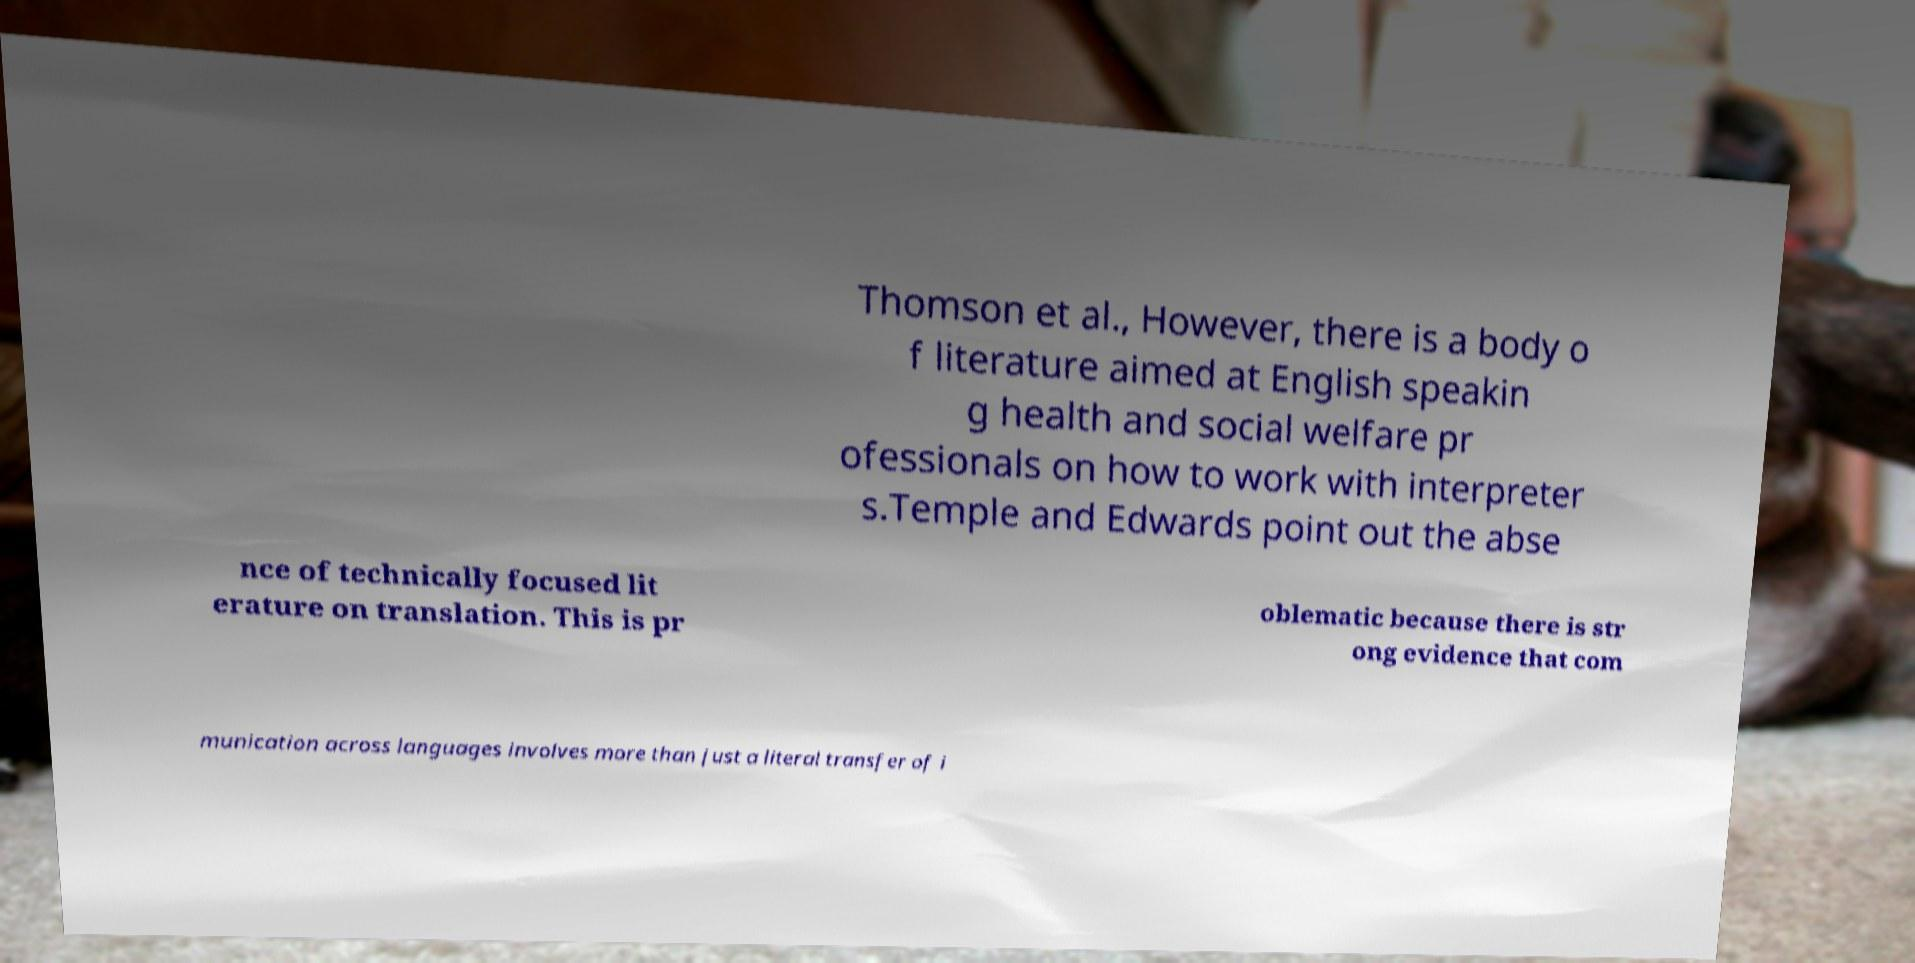Can you read and provide the text displayed in the image?This photo seems to have some interesting text. Can you extract and type it out for me? Thomson et al., However, there is a body o f literature aimed at English speakin g health and social welfare pr ofessionals on how to work with interpreter s.Temple and Edwards point out the abse nce of technically focused lit erature on translation. This is pr oblematic because there is str ong evidence that com munication across languages involves more than just a literal transfer of i 